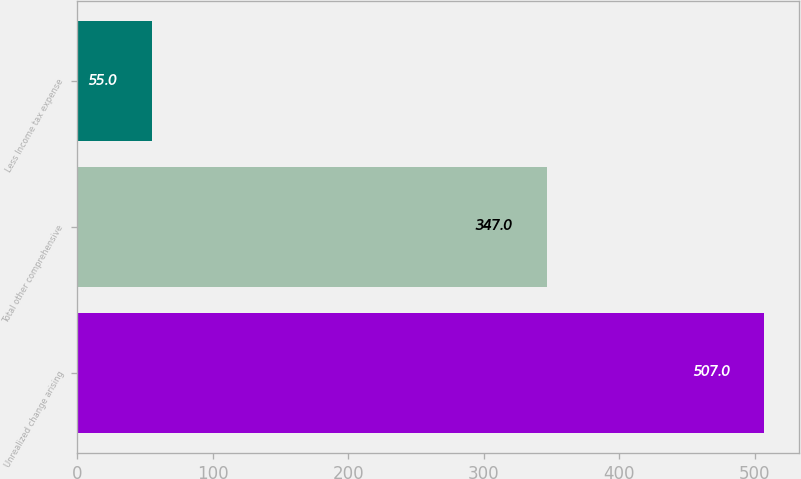<chart> <loc_0><loc_0><loc_500><loc_500><bar_chart><fcel>Unrealized change arising<fcel>Total other comprehensive<fcel>Less Income tax expense<nl><fcel>507<fcel>347<fcel>55<nl></chart> 